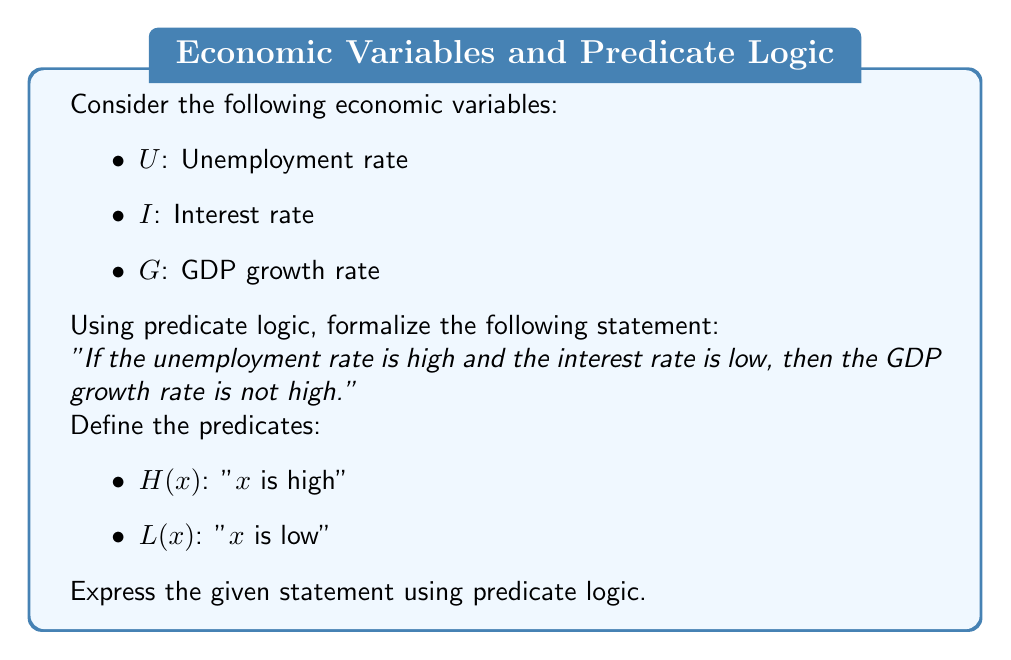Show me your answer to this math problem. Let's break down the statement and formalize it using predicate logic:

1. "The unemployment rate is high": $H(U)$
2. "The interest rate is low": $L(I)$
3. "The GDP growth rate is not high": $\neg H(G)$

Now, we need to combine these predicates using logical connectives:

4. "If the unemployment rate is high and the interest rate is low": $H(U) \wedge L(I)$

5. The entire statement can be expressed as an implication:
   $(H(U) \wedge L(I)) \rightarrow \neg H(G)$

This logical formula reads as: "If $U$ is high and $I$ is low, then $G$ is not high."

The formula uses the following logical symbols:
- $\wedge$ (logical AND)
- $\rightarrow$ (implication)
- $\neg$ (negation)

This predicate logic formulation allows for a precise representation of the relationship between these economic variables, which is crucial for developing predictive models for labor market shifts.
Answer: $(H(U) \wedge L(I)) \rightarrow \neg H(G)$ 